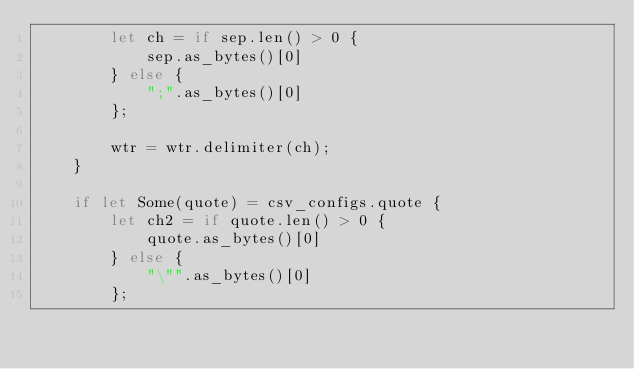<code> <loc_0><loc_0><loc_500><loc_500><_Rust_>        let ch = if sep.len() > 0 {
            sep.as_bytes()[0]
        } else {
            ";".as_bytes()[0]
        };

        wtr = wtr.delimiter(ch);
    }

    if let Some(quote) = csv_configs.quote {
        let ch2 = if quote.len() > 0 {
            quote.as_bytes()[0]
        } else {
            "\"".as_bytes()[0]
        };
</code> 